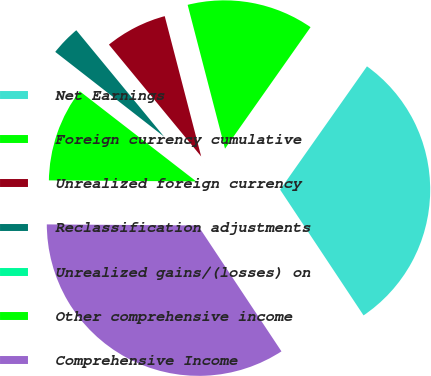<chart> <loc_0><loc_0><loc_500><loc_500><pie_chart><fcel>Net Earnings<fcel>Foreign currency cumulative<fcel>Unrealized foreign currency<fcel>Reclassification adjustments<fcel>Unrealized gains/(losses) on<fcel>Other comprehensive income<fcel>Comprehensive Income<nl><fcel>30.91%<fcel>13.81%<fcel>6.93%<fcel>3.49%<fcel>0.05%<fcel>10.37%<fcel>34.44%<nl></chart> 